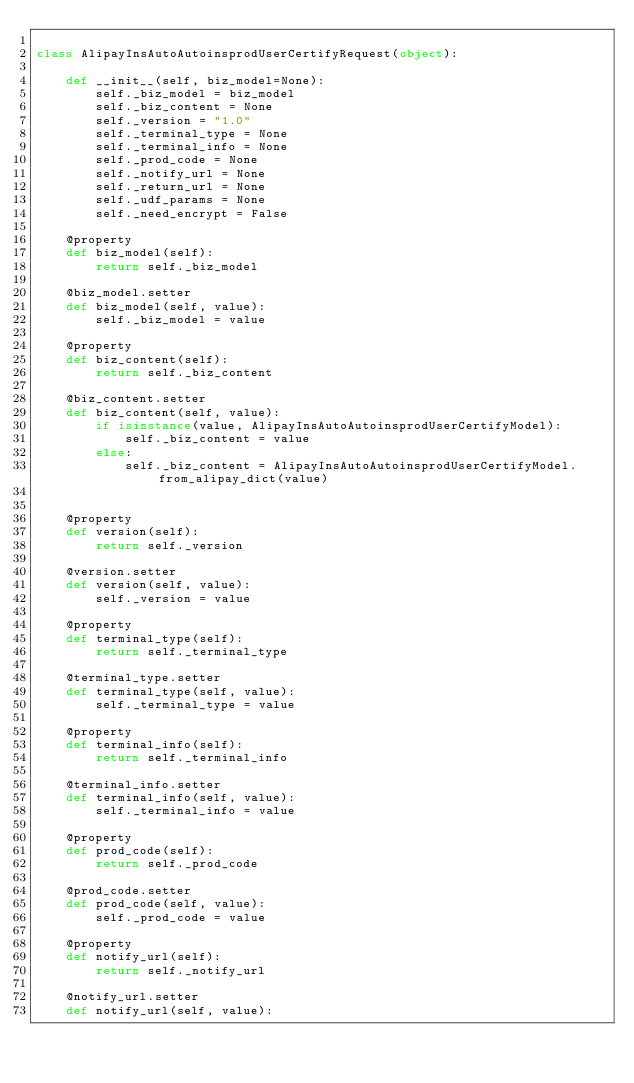Convert code to text. <code><loc_0><loc_0><loc_500><loc_500><_Python_>
class AlipayInsAutoAutoinsprodUserCertifyRequest(object):

    def __init__(self, biz_model=None):
        self._biz_model = biz_model
        self._biz_content = None
        self._version = "1.0"
        self._terminal_type = None
        self._terminal_info = None
        self._prod_code = None
        self._notify_url = None
        self._return_url = None
        self._udf_params = None
        self._need_encrypt = False

    @property
    def biz_model(self):
        return self._biz_model

    @biz_model.setter
    def biz_model(self, value):
        self._biz_model = value

    @property
    def biz_content(self):
        return self._biz_content

    @biz_content.setter
    def biz_content(self, value):
        if isinstance(value, AlipayInsAutoAutoinsprodUserCertifyModel):
            self._biz_content = value
        else:
            self._biz_content = AlipayInsAutoAutoinsprodUserCertifyModel.from_alipay_dict(value)


    @property
    def version(self):
        return self._version

    @version.setter
    def version(self, value):
        self._version = value

    @property
    def terminal_type(self):
        return self._terminal_type

    @terminal_type.setter
    def terminal_type(self, value):
        self._terminal_type = value

    @property
    def terminal_info(self):
        return self._terminal_info

    @terminal_info.setter
    def terminal_info(self, value):
        self._terminal_info = value

    @property
    def prod_code(self):
        return self._prod_code

    @prod_code.setter
    def prod_code(self, value):
        self._prod_code = value

    @property
    def notify_url(self):
        return self._notify_url

    @notify_url.setter
    def notify_url(self, value):</code> 